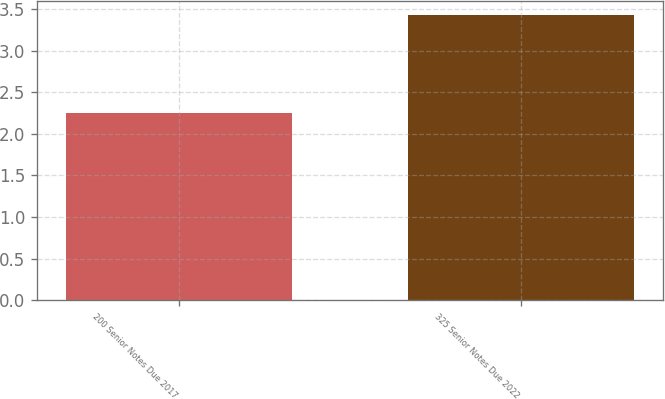<chart> <loc_0><loc_0><loc_500><loc_500><bar_chart><fcel>200 Senior Notes Due 2017<fcel>325 Senior Notes Due 2022<nl><fcel>2.25<fcel>3.43<nl></chart> 